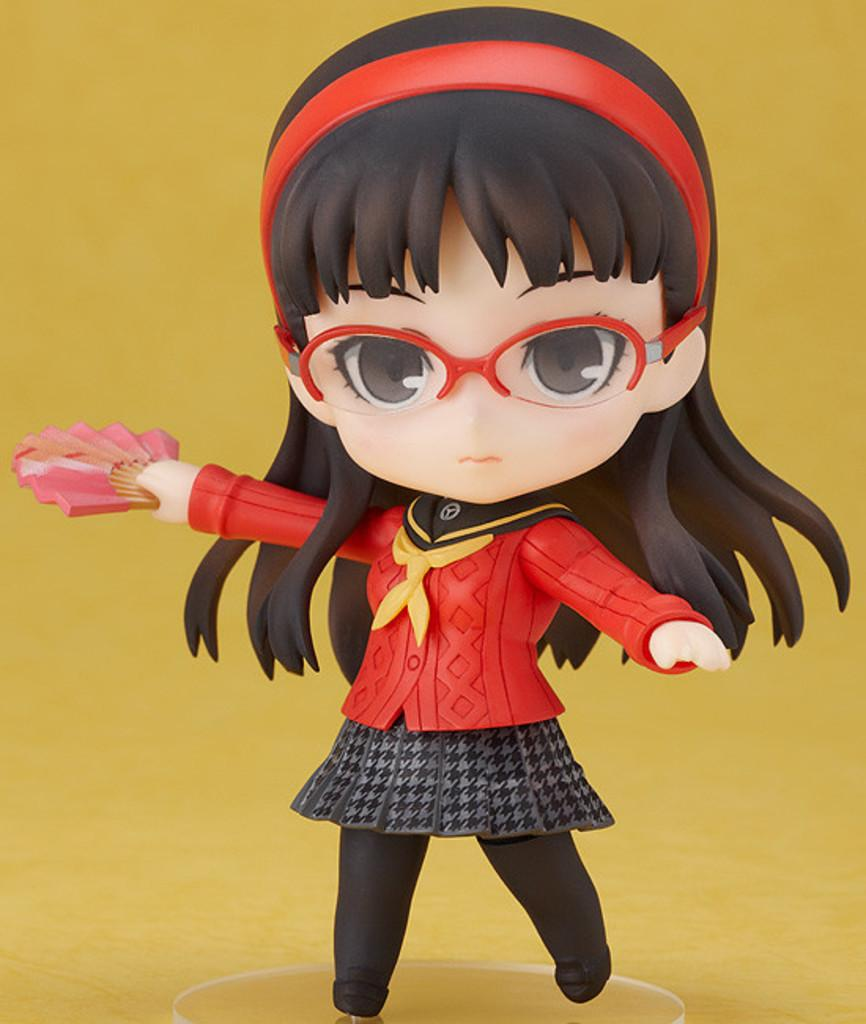What is the main object in the image? There is a toy in the image. Can you describe the toy's appearance? The toy is wearing a dress with red, black, and ash colors, and it has specs. What color is the background of the image? The background of the image is yellow. What reward is the toy receiving for its performance in the cave? There is no mention of a cave or a reward in the image, and the toy is not performing any actions. 